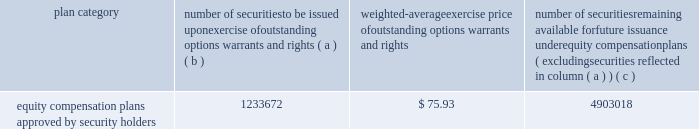Part iii item 10 .
Directors , executive officers and corporate governance for the information required by this item 10 , other than information with respect to our executive officers contained at the end of item 1 of this report , see 201celection of directors , 201d 201cnominees for election to the board of directors , 201d 201ccorporate governance 201d and 201csection 16 ( a ) beneficial ownership reporting compliance , 201d in the proxy statement for our 2015 annual meeting , which information is incorporated herein by reference .
The proxy statement for our 2015 annual meeting will be filed within 120 days of the close of our fiscal year .
For the information required by this item 10 with respect to our executive officers , see part i of this report on pages 11 - 12 .
Item 11 .
Executive compensation for the information required by this item 11 , see 201cexecutive compensation , 201d 201ccompensation committee report on executive compensation 201d and 201ccompensation committee interlocks and insider participation 201d in the proxy statement for our 2015 annual meeting , which information is incorporated herein by reference .
Item 12 .
Security ownership of certain beneficial owners and management and related stockholder matters for the information required by this item 12 with respect to beneficial ownership of our common stock , see 201csecurity ownership of certain beneficial owners and management 201d in the proxy statement for our 2015 annual meeting , which information is incorporated herein by reference .
The table sets forth certain information as of december 31 , 2014 regarding our equity plans : plan category number of securities to be issued upon exercise of outstanding options , warrants and rights weighted-average exercise price of outstanding options , warrants and rights number of securities remaining available for future issuance under equity compensation plans ( excluding securities reflected in column ( a ) ( b ) ( c ) equity compensation plans approved by security holders 1233672 $ 75.93 4903018 item 13 .
Certain relationships and related transactions , and director independence for the information required by this item 13 , see 201ccertain transactions 201d and 201ccorporate governance 201d in the proxy statement for our 2015 annual meeting , which information is incorporated herein by reference .
Item 14 .
Principal accounting fees and services for the information required by this item 14 , see 201caudit and non-audit fees 201d and 201cpolicy on audit committee pre- approval of audit and non-audit services of independent registered public accounting firm 201d in the proxy statement for our 2015 annual meeting , which information is incorporated herein by reference. .
Part iii item 10 .
Directors , executive officers and corporate governance for the information required by this item 10 , other than information with respect to our executive officers contained at the end of item 1 of this report , see 201celection of directors , 201d 201cnominees for election to the board of directors , 201d 201ccorporate governance 201d and 201csection 16 ( a ) beneficial ownership reporting compliance , 201d in the proxy statement for our 2015 annual meeting , which information is incorporated herein by reference .
The proxy statement for our 2015 annual meeting will be filed within 120 days of the close of our fiscal year .
For the information required by this item 10 with respect to our executive officers , see part i of this report on pages 11 - 12 .
Item 11 .
Executive compensation for the information required by this item 11 , see 201cexecutive compensation , 201d 201ccompensation committee report on executive compensation 201d and 201ccompensation committee interlocks and insider participation 201d in the proxy statement for our 2015 annual meeting , which information is incorporated herein by reference .
Item 12 .
Security ownership of certain beneficial owners and management and related stockholder matters for the information required by this item 12 with respect to beneficial ownership of our common stock , see 201csecurity ownership of certain beneficial owners and management 201d in the proxy statement for our 2015 annual meeting , which information is incorporated herein by reference .
The following table sets forth certain information as of december 31 , 2014 regarding our equity plans : plan category number of securities to be issued upon exercise of outstanding options , warrants and rights weighted-average exercise price of outstanding options , warrants and rights number of securities remaining available for future issuance under equity compensation plans ( excluding securities reflected in column ( a ) ( b ) ( c ) equity compensation plans approved by security holders 1233672 $ 75.93 4903018 item 13 .
Certain relationships and related transactions , and director independence for the information required by this item 13 , see 201ccertain transactions 201d and 201ccorporate governance 201d in the proxy statement for our 2015 annual meeting , which information is incorporated herein by reference .
Item 14 .
Principal accounting fees and services for the information required by this item 14 , see 201caudit and non-audit fees 201d and 201cpolicy on audit committee pre- approval of audit and non-audit services of independent registered public accounting firm 201d in the proxy statement for our 2015 annual meeting , which information is incorporated herein by reference. .
What portion of the total number of securities approved by the security holders remains available for future issuance? 
Computations: (4903018 / (1233672 + 4903018))
Answer: 0.79897. Part iii item 10 .
Directors , executive officers and corporate governance for the information required by this item 10 , other than information with respect to our executive officers contained at the end of item 1 of this report , see 201celection of directors , 201d 201cnominees for election to the board of directors , 201d 201ccorporate governance 201d and 201csection 16 ( a ) beneficial ownership reporting compliance , 201d in the proxy statement for our 2015 annual meeting , which information is incorporated herein by reference .
The proxy statement for our 2015 annual meeting will be filed within 120 days of the close of our fiscal year .
For the information required by this item 10 with respect to our executive officers , see part i of this report on pages 11 - 12 .
Item 11 .
Executive compensation for the information required by this item 11 , see 201cexecutive compensation , 201d 201ccompensation committee report on executive compensation 201d and 201ccompensation committee interlocks and insider participation 201d in the proxy statement for our 2015 annual meeting , which information is incorporated herein by reference .
Item 12 .
Security ownership of certain beneficial owners and management and related stockholder matters for the information required by this item 12 with respect to beneficial ownership of our common stock , see 201csecurity ownership of certain beneficial owners and management 201d in the proxy statement for our 2015 annual meeting , which information is incorporated herein by reference .
The table sets forth certain information as of december 31 , 2014 regarding our equity plans : plan category number of securities to be issued upon exercise of outstanding options , warrants and rights weighted-average exercise price of outstanding options , warrants and rights number of securities remaining available for future issuance under equity compensation plans ( excluding securities reflected in column ( a ) ( b ) ( c ) equity compensation plans approved by security holders 1233672 $ 75.93 4903018 item 13 .
Certain relationships and related transactions , and director independence for the information required by this item 13 , see 201ccertain transactions 201d and 201ccorporate governance 201d in the proxy statement for our 2015 annual meeting , which information is incorporated herein by reference .
Item 14 .
Principal accounting fees and services for the information required by this item 14 , see 201caudit and non-audit fees 201d and 201cpolicy on audit committee pre- approval of audit and non-audit services of independent registered public accounting firm 201d in the proxy statement for our 2015 annual meeting , which information is incorporated herein by reference. .
Part iii item 10 .
Directors , executive officers and corporate governance for the information required by this item 10 , other than information with respect to our executive officers contained at the end of item 1 of this report , see 201celection of directors , 201d 201cnominees for election to the board of directors , 201d 201ccorporate governance 201d and 201csection 16 ( a ) beneficial ownership reporting compliance , 201d in the proxy statement for our 2015 annual meeting , which information is incorporated herein by reference .
The proxy statement for our 2015 annual meeting will be filed within 120 days of the close of our fiscal year .
For the information required by this item 10 with respect to our executive officers , see part i of this report on pages 11 - 12 .
Item 11 .
Executive compensation for the information required by this item 11 , see 201cexecutive compensation , 201d 201ccompensation committee report on executive compensation 201d and 201ccompensation committee interlocks and insider participation 201d in the proxy statement for our 2015 annual meeting , which information is incorporated herein by reference .
Item 12 .
Security ownership of certain beneficial owners and management and related stockholder matters for the information required by this item 12 with respect to beneficial ownership of our common stock , see 201csecurity ownership of certain beneficial owners and management 201d in the proxy statement for our 2015 annual meeting , which information is incorporated herein by reference .
The following table sets forth certain information as of december 31 , 2014 regarding our equity plans : plan category number of securities to be issued upon exercise of outstanding options , warrants and rights weighted-average exercise price of outstanding options , warrants and rights number of securities remaining available for future issuance under equity compensation plans ( excluding securities reflected in column ( a ) ( b ) ( c ) equity compensation plans approved by security holders 1233672 $ 75.93 4903018 item 13 .
Certain relationships and related transactions , and director independence for the information required by this item 13 , see 201ccertain transactions 201d and 201ccorporate governance 201d in the proxy statement for our 2015 annual meeting , which information is incorporated herein by reference .
Item 14 .
Principal accounting fees and services for the information required by this item 14 , see 201caudit and non-audit fees 201d and 201cpolicy on audit committee pre- approval of audit and non-audit services of independent registered public accounting firm 201d in the proxy statement for our 2015 annual meeting , which information is incorporated herein by reference. .
What is the ratio of issued units to outstanding units? 
Computations: (1233672 / 4903018)
Answer: 0.25161. 